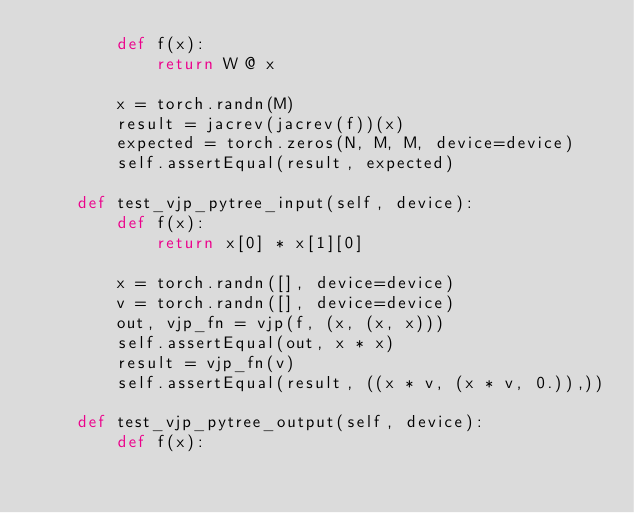Convert code to text. <code><loc_0><loc_0><loc_500><loc_500><_Python_>        def f(x):
            return W @ x

        x = torch.randn(M)
        result = jacrev(jacrev(f))(x)
        expected = torch.zeros(N, M, M, device=device)
        self.assertEqual(result, expected)

    def test_vjp_pytree_input(self, device):
        def f(x):
            return x[0] * x[1][0]

        x = torch.randn([], device=device)
        v = torch.randn([], device=device)
        out, vjp_fn = vjp(f, (x, (x, x)))
        self.assertEqual(out, x * x)
        result = vjp_fn(v)
        self.assertEqual(result, ((x * v, (x * v, 0.)),))

    def test_vjp_pytree_output(self, device):
        def f(x):</code> 